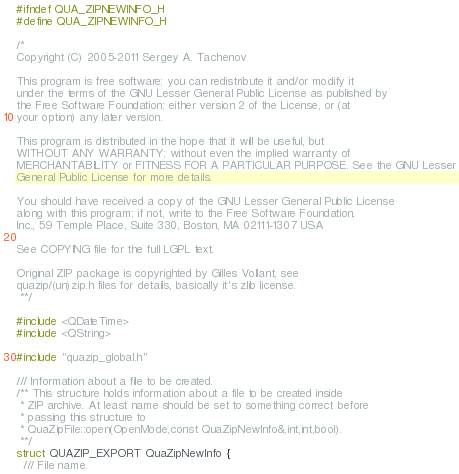Convert code to text. <code><loc_0><loc_0><loc_500><loc_500><_C_>#ifndef QUA_ZIPNEWINFO_H
#define QUA_ZIPNEWINFO_H

/*
Copyright (C) 2005-2011 Sergey A. Tachenov

This program is free software; you can redistribute it and/or modify it
under the terms of the GNU Lesser General Public License as published by
the Free Software Foundation; either version 2 of the License, or (at
your option) any later version.

This program is distributed in the hope that it will be useful, but
WITHOUT ANY WARRANTY; without even the implied warranty of
MERCHANTABILITY or FITNESS FOR A PARTICULAR PURPOSE. See the GNU Lesser
General Public License for more details.

You should have received a copy of the GNU Lesser General Public License
along with this program; if not, write to the Free Software Foundation,
Inc., 59 Temple Place, Suite 330, Boston, MA 02111-1307 USA

See COPYING file for the full LGPL text.

Original ZIP package is copyrighted by Gilles Vollant, see
quazip/(un)zip.h files for details, basically it's zlib license.
 **/

#include <QDateTime>
#include <QString>

#include "quazip_global.h"

/// Information about a file to be created.
/** This structure holds information about a file to be created inside
 * ZIP archive. At least name should be set to something correct before
 * passing this structure to
 * QuaZipFile::open(OpenMode,const QuaZipNewInfo&,int,int,bool).
 **/
struct QUAZIP_EXPORT QuaZipNewInfo {
  /// File name.</code> 